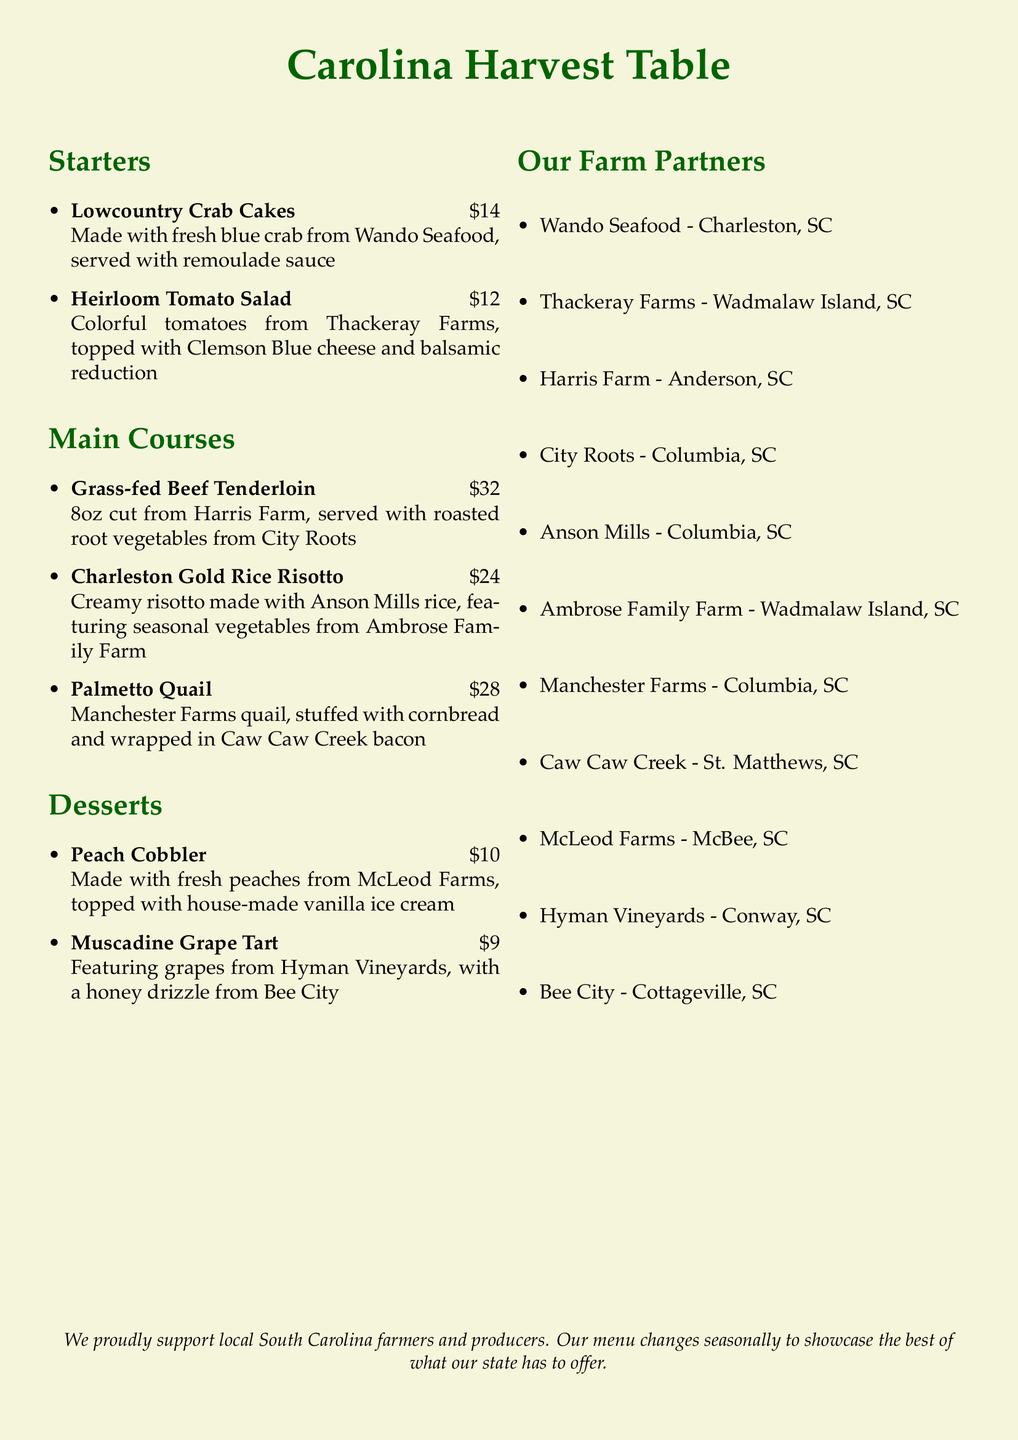What is the price of the Lowcountry Crab Cakes? The price is mentioned next to the dish name on the menu.
Answer: $14 Which farm produces the blue crab used in the crab cakes? The document provides the source of the ingredients for the dishes, including the blue crab.
Answer: Wando Seafood What type of cheese is used in the Heirloom Tomato Salad? The salad description indicates the specific type of cheese included.
Answer: Clemson Blue cheese How many ounces is the Grass-fed Beef Tenderloin? The menu states the size of the beef tenderloin cut.
Answer: 8oz Which dessert is made with fresh peaches? The dessert section indicates which dish utilizes peaches.
Answer: Peach Cobbler What farm provides the rice for the Charleston Gold Rice Risotto? The risotto description includes the source of the rice.
Answer: Anson Mills Which farm is located in McBee, SC? The list of farm partners indicates the location of each farm.
Answer: McLeod Farms What type of bird is the Palmetto Quail? The main courses section describes this specific dish.
Answer: Quail How much does the Muscadine Grape Tart cost? The price is provided alongside the dessert name.
Answer: $9 